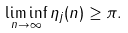<formula> <loc_0><loc_0><loc_500><loc_500>\liminf _ { n \to \infty } \eta _ { j } ( n ) \geq \pi .</formula> 